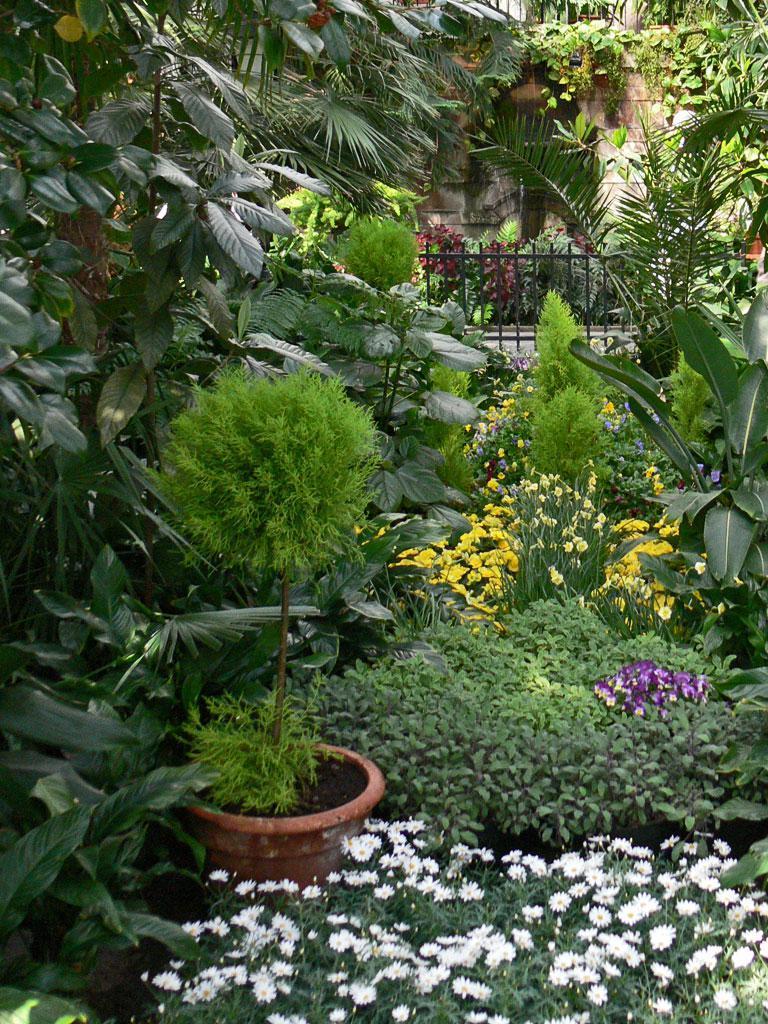Please provide a concise description of this image. In this image I see number of plants and I see flowers which are of white, violet and yellow in color and I see the fencing over here and I see the wall. 